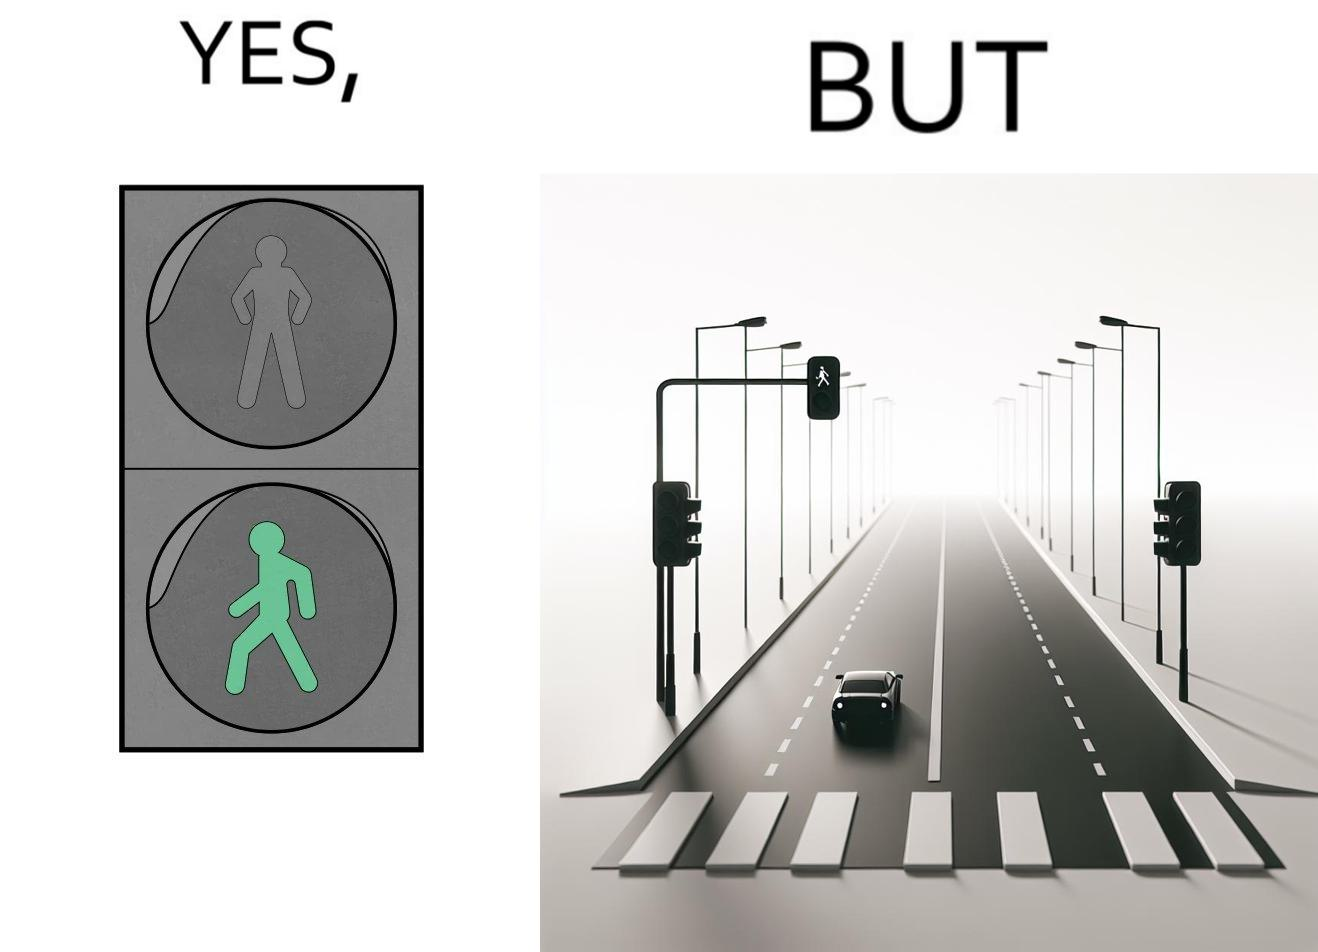Is this a satirical image? Yes, this image is satirical. 